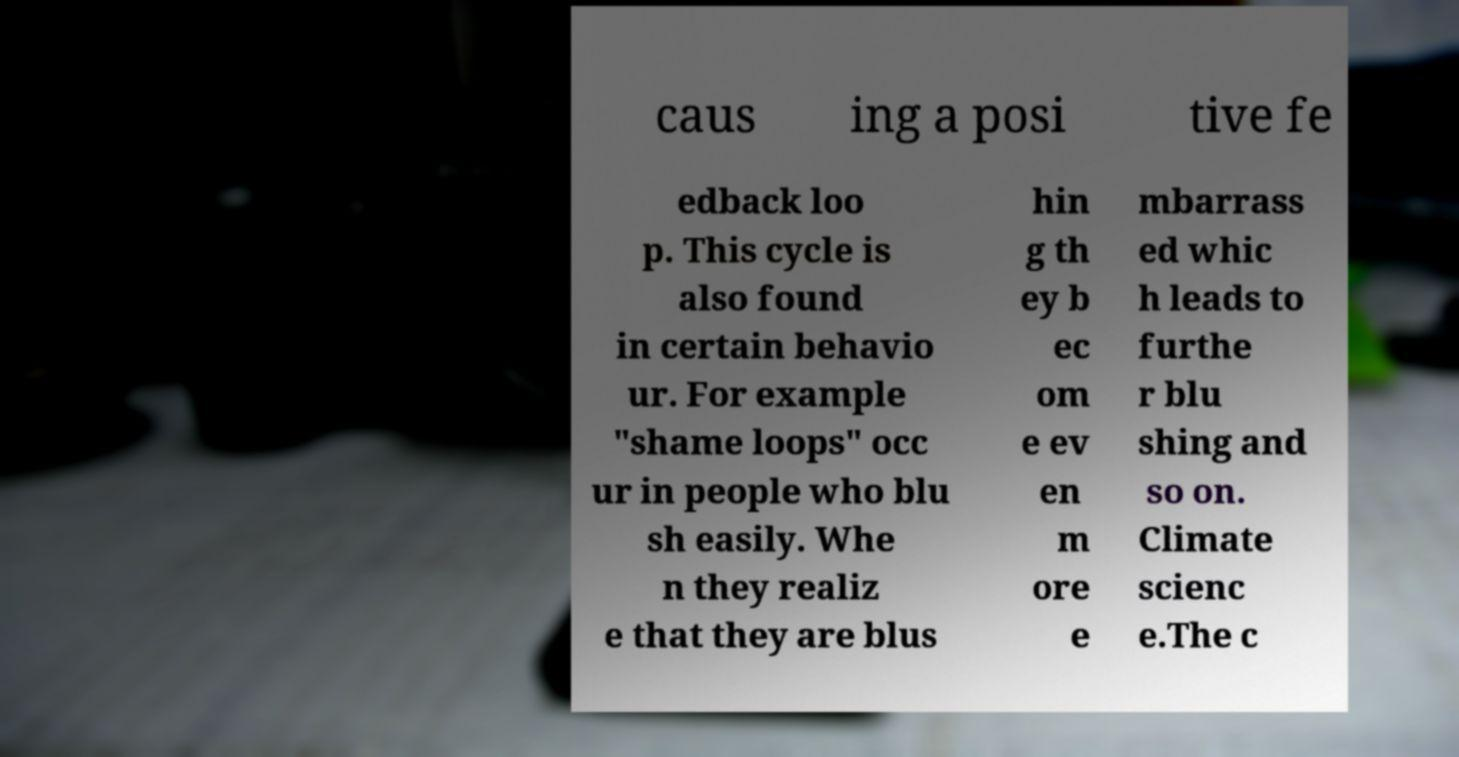I need the written content from this picture converted into text. Can you do that? caus ing a posi tive fe edback loo p. This cycle is also found in certain behavio ur. For example "shame loops" occ ur in people who blu sh easily. Whe n they realiz e that they are blus hin g th ey b ec om e ev en m ore e mbarrass ed whic h leads to furthe r blu shing and so on. Climate scienc e.The c 